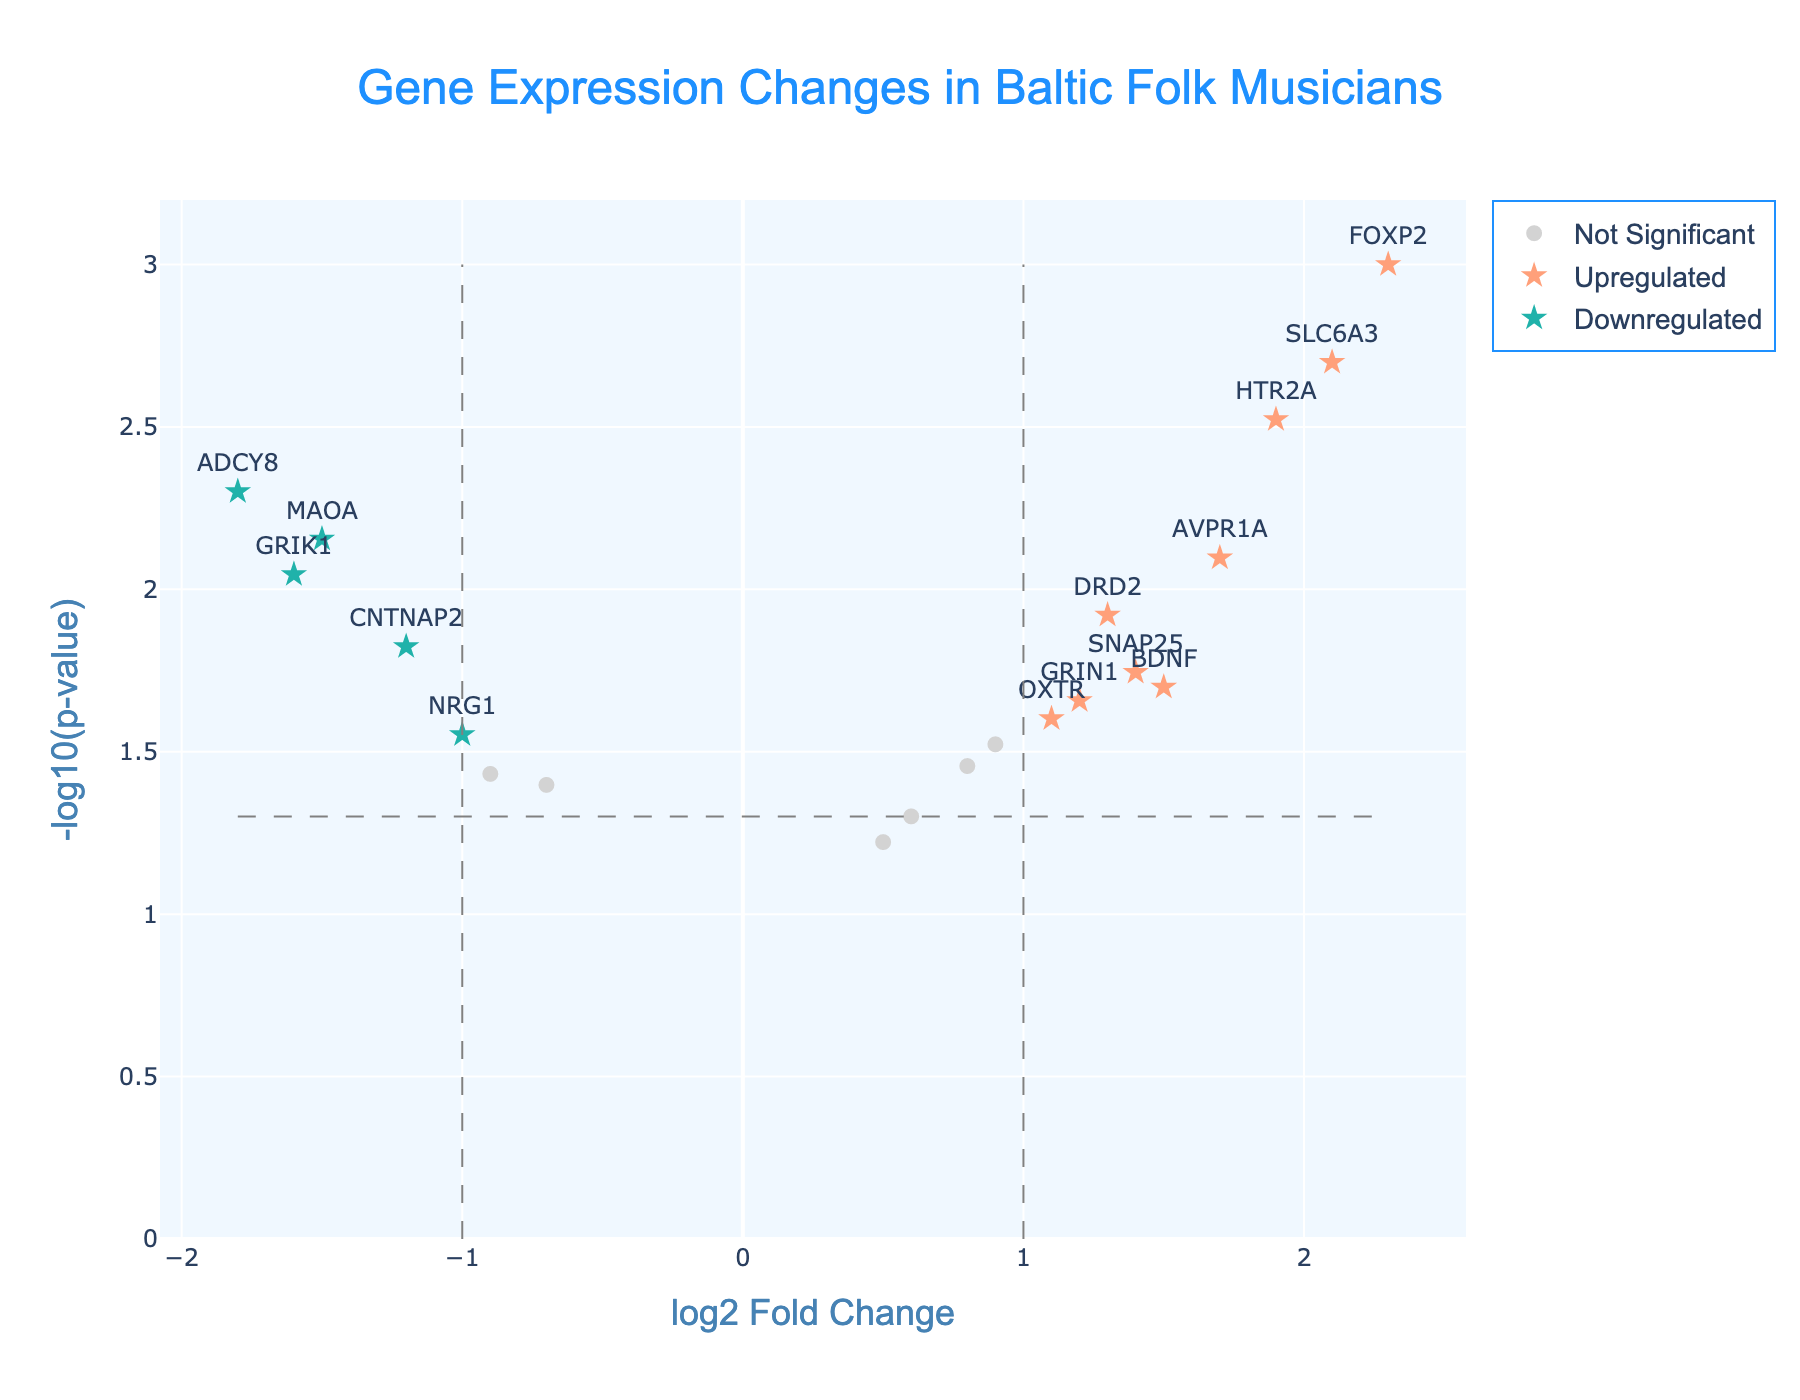What is the title of the plot? The title of the plot is displayed at the top of the figure. It reads "Gene Expression Changes in Baltic Folk Musicians".
Answer: Gene Expression Changes in Baltic Folk Musicians How many genes are significantly upregulated? To determine the number of significantly upregulated genes, look for points that are orange stars, which represent genes with a log2 Fold Change (log2FC) greater than or equal to 1 and a p-value less than or equal to 0.05. Counting these points yields 5 genes.
Answer: 5 Which gene has the highest log2 Fold Change? Observe the x-axis for the gene with the furthest positive value. The gene SLC6A3 is represented at the highest positive log2 Fold Change (2.1).
Answer: SLC6A3 Which gene has the lowest p-value? On a volcano plot, the lowest p-value corresponds to the highest value on the y-axis. The gene FOXP2 has the highest -log10(p-value), hence the lowest p-value.
Answer: FOXP2 Are there more significant upregulated genes or downregulated genes? Count the number of orange stars (upregulated genes) and count the number of blue stars (downregulated genes). There are 5 significantly upregulated genes and 4 significantly downregulated genes. There are more upregulated genes.
Answer: Upregulated What is the log2 Fold Change and p-value of the gene MAOA? Identify the position of the gene MAOA on the plot. The hover text or the plot legend shows the values. For MAOA, log2 Fold Change is -1.5, and the p-value is 0.007.
Answer: log2FC: -1.5, p-value: 0.007 Which of the significant downregulated genes has the lowest log2 Fold Change? Look at the significantly downregulated genes represented by blue stars and identify the one that is furthest to the left on the x-axis. GRIK1 has the lowest log2 Fold Change of -1.6.
Answer: GRIK1 What is the range of -log10(p-value) across all genes? Determine the maximum and minimum values on the y-axis representing -log10(p-value). The highest value is approximately 3, and the lowest is just about 1.3. So the range is from 1.3 to 3.
Answer: 1.3 to 3 What is the color and shape used to represent non-significant genes? Non-significant genes are represented with light grey circles. These genes either have a log2FC with an absolute value less than 1 or a p-value greater than 0.05.
Answer: Light grey circles Is the gene OXTR significantly expressed? Check the position of the gene OXTR on the plot. It is represented by a light grey circle, indicating it is not significantly expressed.
Answer: No 